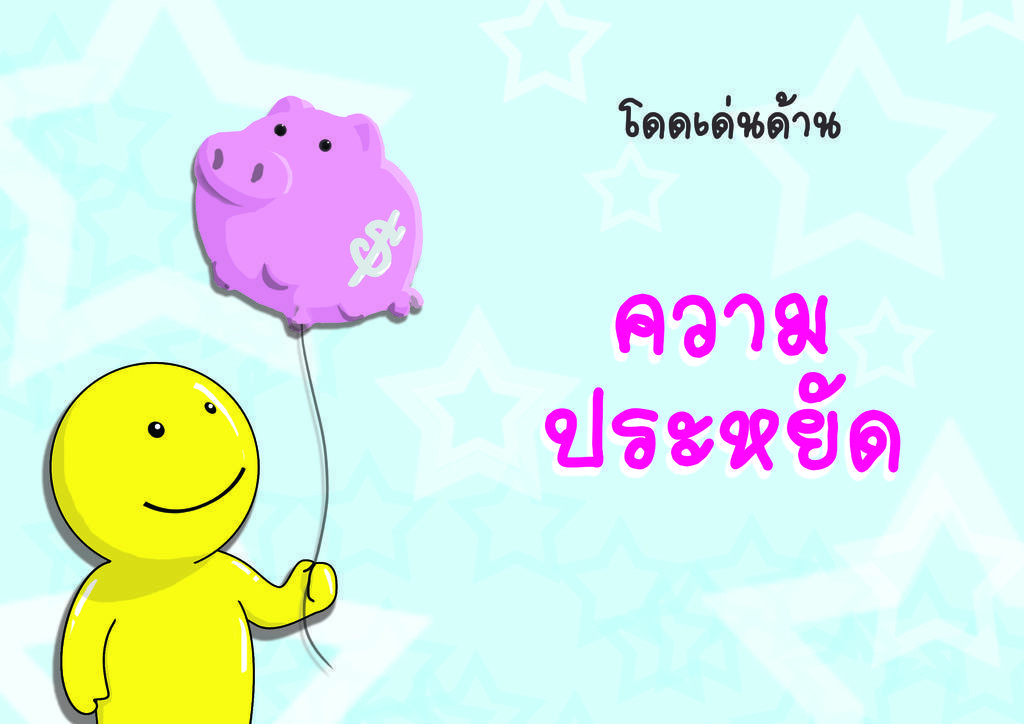How would you summarize this image in a sentence or two? In this image I can see the yellow color toy holding the pink color balloon. To the side I can see something is written. And there is a blue background. 